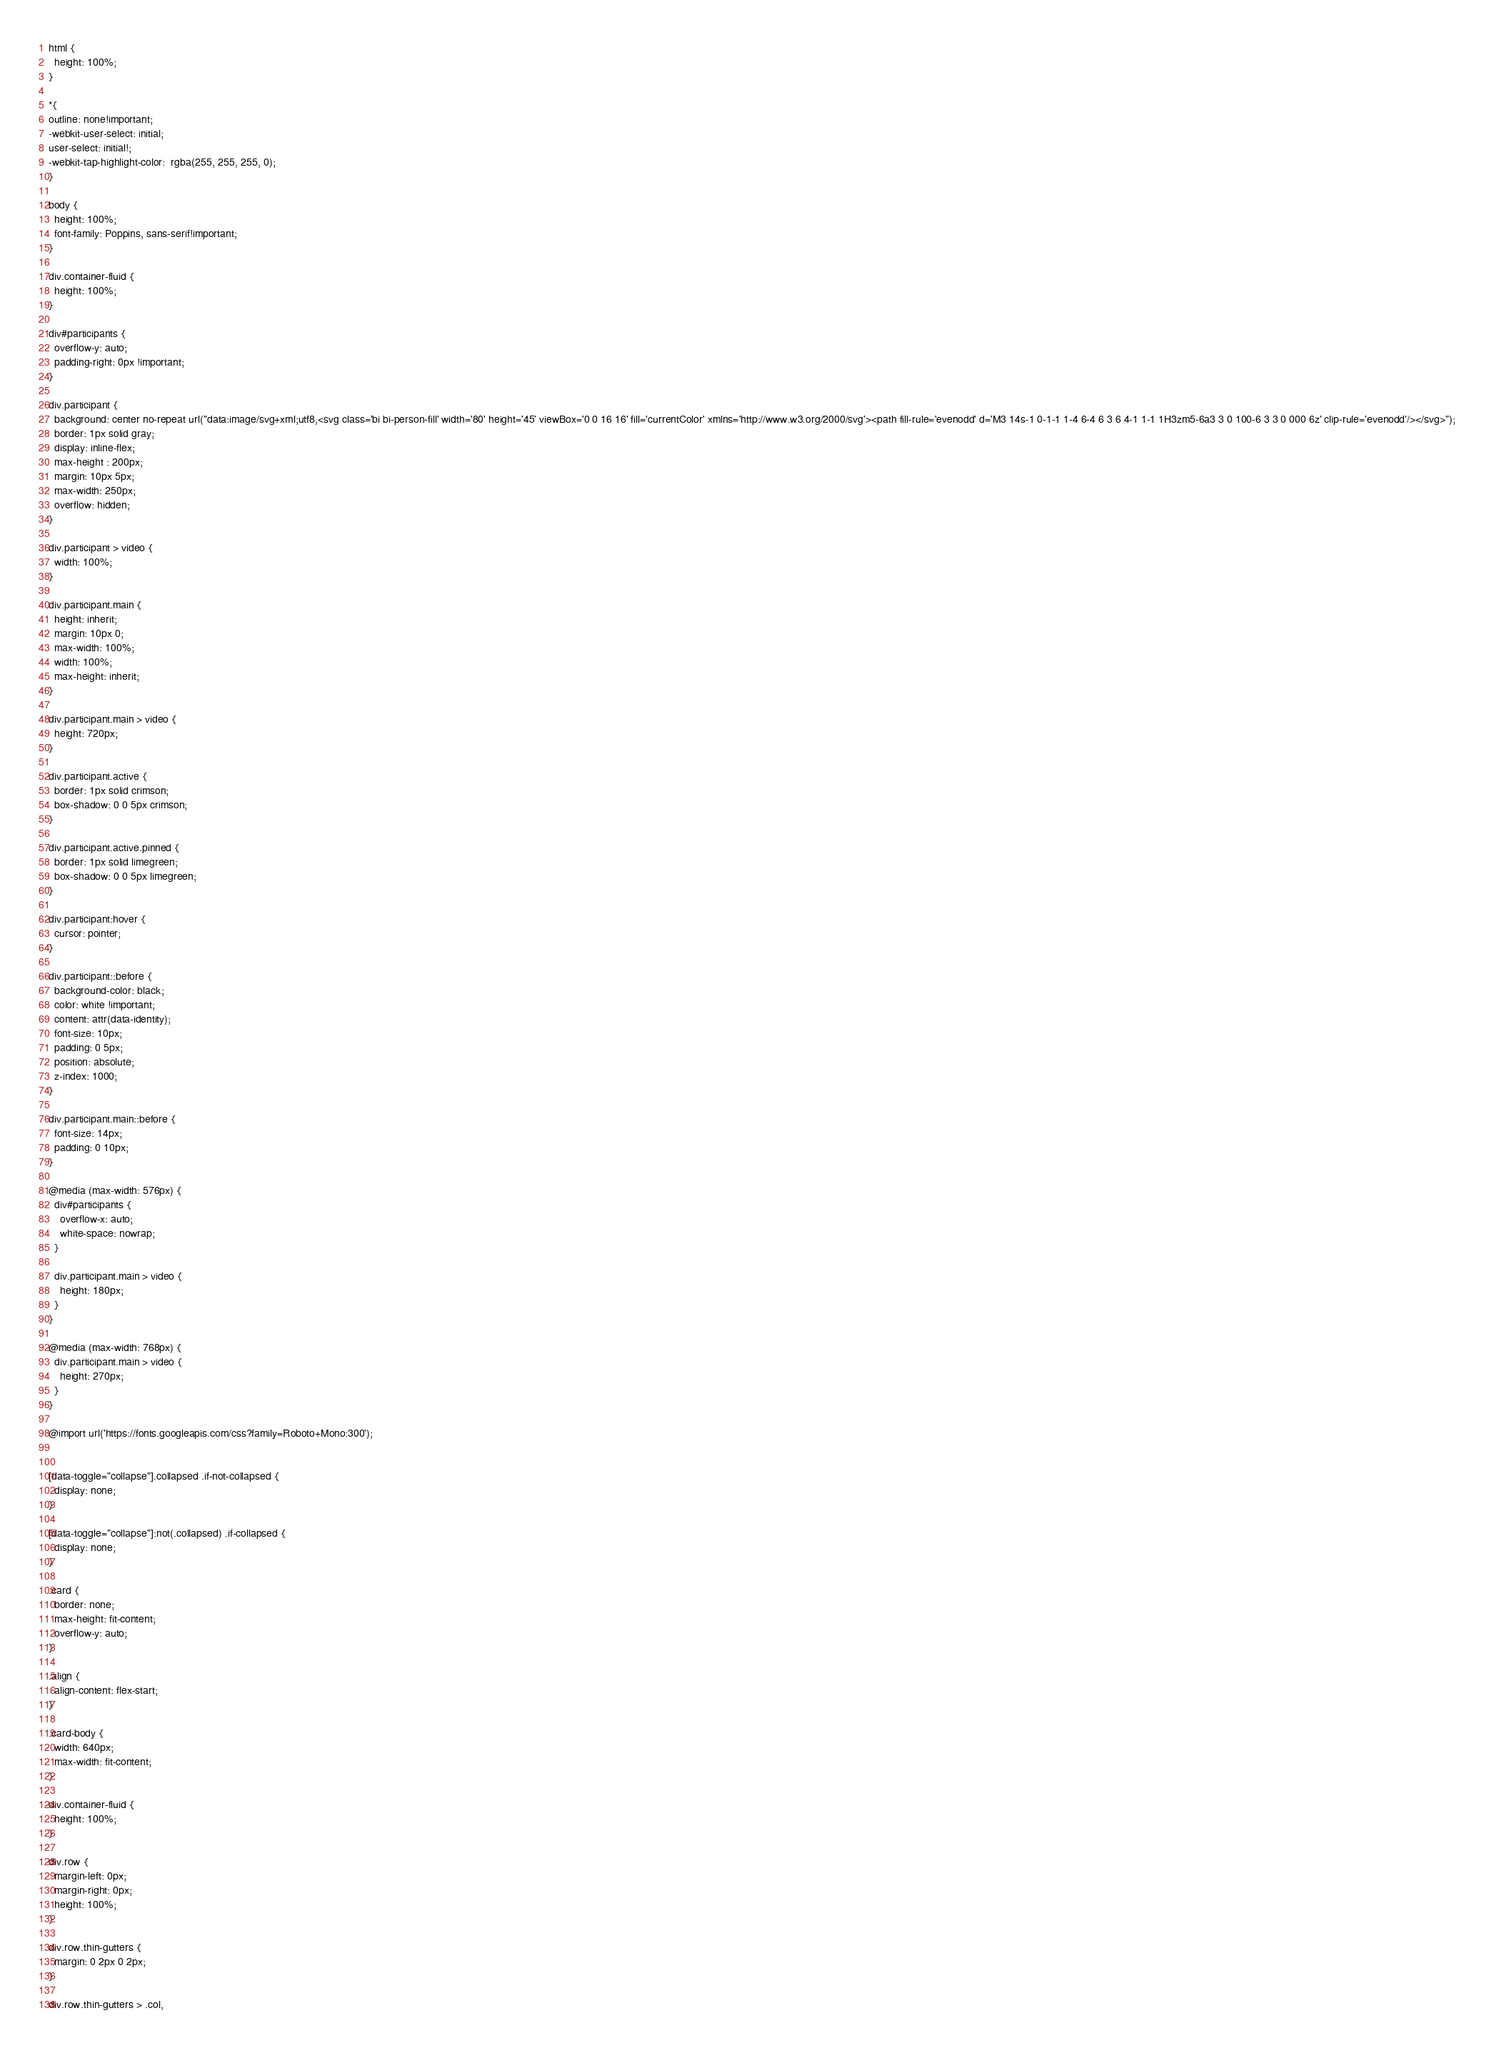Convert code to text. <code><loc_0><loc_0><loc_500><loc_500><_CSS_>html {
  height: 100%;
}

*{
outline: none!important;
-webkit-user-select: initial;
user-select: initial!;
-webkit-tap-highlight-color:  rgba(255, 255, 255, 0);    
}

body {
  height: 100%;
  font-family: Poppins, sans-serif!important;
}

div.container-fluid {
  height: 100%;
}

div#participants {
  overflow-y: auto;
  padding-right: 0px !important;
}

div.participant {
  background: center no-repeat url("data:image/svg+xml;utf8,<svg class='bi bi-person-fill' width='80' height='45' viewBox='0 0 16 16' fill='currentColor' xmlns='http://www.w3.org/2000/svg'><path fill-rule='evenodd' d='M3 14s-1 0-1-1 1-4 6-4 6 3 6 4-1 1-1 1H3zm5-6a3 3 0 100-6 3 3 0 000 6z' clip-rule='evenodd'/></svg>");
  border: 1px solid gray;
  display: inline-flex;
  max-height : 200px;
  margin: 10px 5px;
  max-width: 250px;
  overflow: hidden;
}

div.participant > video {
  width: 100%;
}

div.participant.main {
  height: inherit;
  margin: 10px 0;
  max-width: 100%;
  width: 100%;
  max-height: inherit;
}

div.participant.main > video {
  height: 720px;
}

div.participant.active {
  border: 1px solid crimson;
  box-shadow: 0 0 5px crimson;
}

div.participant.active.pinned {
  border: 1px solid limegreen;
  box-shadow: 0 0 5px limegreen;
}

div.participant:hover {
  cursor: pointer;
}

div.participant::before {
  background-color: black;
  color: white !important;
  content: attr(data-identity);
  font-size: 10px;
  padding: 0 5px;
  position: absolute;
  z-index: 1000;
}

div.participant.main::before {
  font-size: 14px;
  padding: 0 10px;
}

@media (max-width: 576px) {
  div#participants {
    overflow-x: auto;
    white-space: nowrap;
  }

  div.participant.main > video {
    height: 180px;
  }
}

@media (max-width: 768px) {
  div.participant.main > video {
    height: 270px;
  }
}

@import url('https://fonts.googleapis.com/css?family=Roboto+Mono:300');


[data-toggle="collapse"].collapsed .if-not-collapsed {
  display: none;
}

[data-toggle="collapse"]:not(.collapsed) .if-collapsed {
  display: none;
}

.card {
  border: none;
  max-height: fit-content;
  overflow-y: auto;
}

.align {
  align-content: flex-start;
}

.card-body {
  width: 640px;
  max-width: fit-content;
}

div.container-fluid {
  height: 100%;
}

div.row {
  margin-left: 0px;
  margin-right: 0px;
  height: 100%;
}

div.row.thin-gutters {
  margin: 0 2px 0 2px;
}

div.row.thin-gutters > .col,</code> 